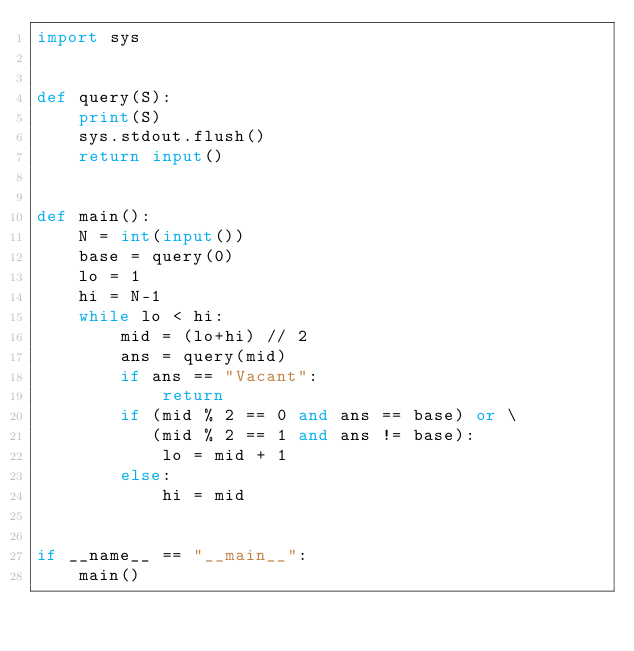<code> <loc_0><loc_0><loc_500><loc_500><_Python_>import sys


def query(S):
    print(S)
    sys.stdout.flush()
    return input()


def main():
    N = int(input())
    base = query(0)
    lo = 1
    hi = N-1
    while lo < hi:
        mid = (lo+hi) // 2
        ans = query(mid)
        if ans == "Vacant":
            return
        if (mid % 2 == 0 and ans == base) or \
           (mid % 2 == 1 and ans != base):
            lo = mid + 1
        else:
            hi = mid


if __name__ == "__main__":
    main()
</code> 